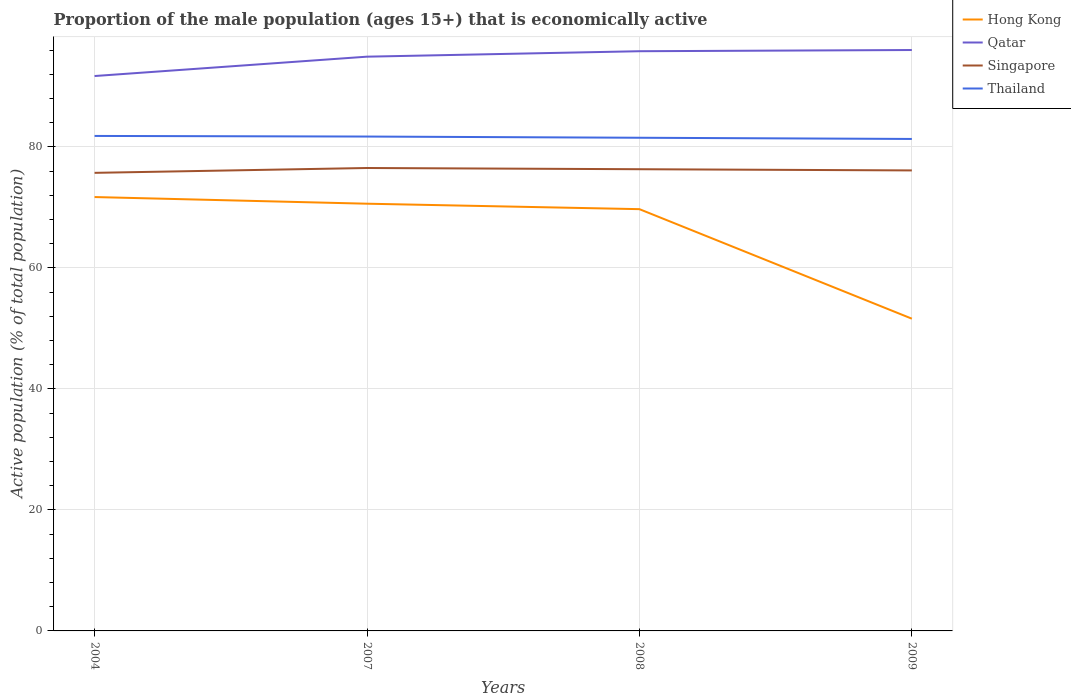How many different coloured lines are there?
Give a very brief answer. 4. Does the line corresponding to Hong Kong intersect with the line corresponding to Singapore?
Provide a short and direct response. No. Across all years, what is the maximum proportion of the male population that is economically active in Singapore?
Offer a terse response. 75.7. What is the total proportion of the male population that is economically active in Qatar in the graph?
Offer a very short reply. -4.3. What is the difference between the highest and the second highest proportion of the male population that is economically active in Singapore?
Make the answer very short. 0.8. What is the difference between the highest and the lowest proportion of the male population that is economically active in Singapore?
Provide a short and direct response. 2. How many lines are there?
Provide a short and direct response. 4. How many years are there in the graph?
Your answer should be very brief. 4. Are the values on the major ticks of Y-axis written in scientific E-notation?
Your answer should be very brief. No. Where does the legend appear in the graph?
Make the answer very short. Top right. What is the title of the graph?
Your answer should be compact. Proportion of the male population (ages 15+) that is economically active. What is the label or title of the Y-axis?
Offer a terse response. Active population (% of total population). What is the Active population (% of total population) of Hong Kong in 2004?
Your answer should be very brief. 71.7. What is the Active population (% of total population) in Qatar in 2004?
Your answer should be very brief. 91.7. What is the Active population (% of total population) in Singapore in 2004?
Offer a very short reply. 75.7. What is the Active population (% of total population) of Thailand in 2004?
Ensure brevity in your answer.  81.8. What is the Active population (% of total population) of Hong Kong in 2007?
Offer a terse response. 70.6. What is the Active population (% of total population) in Qatar in 2007?
Offer a very short reply. 94.9. What is the Active population (% of total population) of Singapore in 2007?
Give a very brief answer. 76.5. What is the Active population (% of total population) in Thailand in 2007?
Your response must be concise. 81.7. What is the Active population (% of total population) of Hong Kong in 2008?
Provide a succinct answer. 69.7. What is the Active population (% of total population) in Qatar in 2008?
Offer a very short reply. 95.8. What is the Active population (% of total population) in Singapore in 2008?
Your answer should be very brief. 76.3. What is the Active population (% of total population) in Thailand in 2008?
Give a very brief answer. 81.5. What is the Active population (% of total population) of Hong Kong in 2009?
Provide a succinct answer. 51.6. What is the Active population (% of total population) in Qatar in 2009?
Ensure brevity in your answer.  96. What is the Active population (% of total population) in Singapore in 2009?
Ensure brevity in your answer.  76.1. What is the Active population (% of total population) of Thailand in 2009?
Make the answer very short. 81.3. Across all years, what is the maximum Active population (% of total population) of Hong Kong?
Your answer should be compact. 71.7. Across all years, what is the maximum Active population (% of total population) of Qatar?
Keep it short and to the point. 96. Across all years, what is the maximum Active population (% of total population) in Singapore?
Give a very brief answer. 76.5. Across all years, what is the maximum Active population (% of total population) of Thailand?
Make the answer very short. 81.8. Across all years, what is the minimum Active population (% of total population) of Hong Kong?
Your answer should be compact. 51.6. Across all years, what is the minimum Active population (% of total population) of Qatar?
Your answer should be compact. 91.7. Across all years, what is the minimum Active population (% of total population) of Singapore?
Ensure brevity in your answer.  75.7. Across all years, what is the minimum Active population (% of total population) of Thailand?
Ensure brevity in your answer.  81.3. What is the total Active population (% of total population) of Hong Kong in the graph?
Your answer should be very brief. 263.6. What is the total Active population (% of total population) of Qatar in the graph?
Keep it short and to the point. 378.4. What is the total Active population (% of total population) in Singapore in the graph?
Your answer should be very brief. 304.6. What is the total Active population (% of total population) of Thailand in the graph?
Your answer should be very brief. 326.3. What is the difference between the Active population (% of total population) of Qatar in 2004 and that in 2007?
Provide a short and direct response. -3.2. What is the difference between the Active population (% of total population) of Qatar in 2004 and that in 2008?
Provide a succinct answer. -4.1. What is the difference between the Active population (% of total population) in Hong Kong in 2004 and that in 2009?
Give a very brief answer. 20.1. What is the difference between the Active population (% of total population) of Qatar in 2004 and that in 2009?
Provide a succinct answer. -4.3. What is the difference between the Active population (% of total population) in Thailand in 2004 and that in 2009?
Offer a terse response. 0.5. What is the difference between the Active population (% of total population) of Singapore in 2007 and that in 2008?
Your response must be concise. 0.2. What is the difference between the Active population (% of total population) in Thailand in 2007 and that in 2008?
Give a very brief answer. 0.2. What is the difference between the Active population (% of total population) of Hong Kong in 2007 and that in 2009?
Provide a short and direct response. 19. What is the difference between the Active population (% of total population) of Thailand in 2007 and that in 2009?
Keep it short and to the point. 0.4. What is the difference between the Active population (% of total population) in Qatar in 2008 and that in 2009?
Your answer should be very brief. -0.2. What is the difference between the Active population (% of total population) in Singapore in 2008 and that in 2009?
Your answer should be compact. 0.2. What is the difference between the Active population (% of total population) of Thailand in 2008 and that in 2009?
Ensure brevity in your answer.  0.2. What is the difference between the Active population (% of total population) of Hong Kong in 2004 and the Active population (% of total population) of Qatar in 2007?
Offer a very short reply. -23.2. What is the difference between the Active population (% of total population) of Qatar in 2004 and the Active population (% of total population) of Thailand in 2007?
Ensure brevity in your answer.  10. What is the difference between the Active population (% of total population) in Hong Kong in 2004 and the Active population (% of total population) in Qatar in 2008?
Your answer should be very brief. -24.1. What is the difference between the Active population (% of total population) of Hong Kong in 2004 and the Active population (% of total population) of Singapore in 2008?
Offer a very short reply. -4.6. What is the difference between the Active population (% of total population) in Singapore in 2004 and the Active population (% of total population) in Thailand in 2008?
Make the answer very short. -5.8. What is the difference between the Active population (% of total population) of Hong Kong in 2004 and the Active population (% of total population) of Qatar in 2009?
Your answer should be compact. -24.3. What is the difference between the Active population (% of total population) of Hong Kong in 2004 and the Active population (% of total population) of Singapore in 2009?
Make the answer very short. -4.4. What is the difference between the Active population (% of total population) of Hong Kong in 2004 and the Active population (% of total population) of Thailand in 2009?
Give a very brief answer. -9.6. What is the difference between the Active population (% of total population) of Qatar in 2004 and the Active population (% of total population) of Singapore in 2009?
Make the answer very short. 15.6. What is the difference between the Active population (% of total population) in Qatar in 2004 and the Active population (% of total population) in Thailand in 2009?
Your answer should be very brief. 10.4. What is the difference between the Active population (% of total population) in Singapore in 2004 and the Active population (% of total population) in Thailand in 2009?
Your answer should be very brief. -5.6. What is the difference between the Active population (% of total population) in Hong Kong in 2007 and the Active population (% of total population) in Qatar in 2008?
Keep it short and to the point. -25.2. What is the difference between the Active population (% of total population) in Qatar in 2007 and the Active population (% of total population) in Singapore in 2008?
Your response must be concise. 18.6. What is the difference between the Active population (% of total population) of Hong Kong in 2007 and the Active population (% of total population) of Qatar in 2009?
Your response must be concise. -25.4. What is the difference between the Active population (% of total population) of Hong Kong in 2007 and the Active population (% of total population) of Thailand in 2009?
Give a very brief answer. -10.7. What is the difference between the Active population (% of total population) of Qatar in 2007 and the Active population (% of total population) of Singapore in 2009?
Keep it short and to the point. 18.8. What is the difference between the Active population (% of total population) of Singapore in 2007 and the Active population (% of total population) of Thailand in 2009?
Offer a very short reply. -4.8. What is the difference between the Active population (% of total population) in Hong Kong in 2008 and the Active population (% of total population) in Qatar in 2009?
Make the answer very short. -26.3. What is the difference between the Active population (% of total population) in Hong Kong in 2008 and the Active population (% of total population) in Singapore in 2009?
Provide a short and direct response. -6.4. What is the difference between the Active population (% of total population) in Hong Kong in 2008 and the Active population (% of total population) in Thailand in 2009?
Your response must be concise. -11.6. What is the difference between the Active population (% of total population) of Qatar in 2008 and the Active population (% of total population) of Singapore in 2009?
Ensure brevity in your answer.  19.7. What is the average Active population (% of total population) of Hong Kong per year?
Keep it short and to the point. 65.9. What is the average Active population (% of total population) in Qatar per year?
Provide a short and direct response. 94.6. What is the average Active population (% of total population) in Singapore per year?
Your response must be concise. 76.15. What is the average Active population (% of total population) of Thailand per year?
Offer a very short reply. 81.58. In the year 2004, what is the difference between the Active population (% of total population) in Hong Kong and Active population (% of total population) in Thailand?
Give a very brief answer. -10.1. In the year 2004, what is the difference between the Active population (% of total population) of Qatar and Active population (% of total population) of Thailand?
Offer a very short reply. 9.9. In the year 2004, what is the difference between the Active population (% of total population) in Singapore and Active population (% of total population) in Thailand?
Offer a very short reply. -6.1. In the year 2007, what is the difference between the Active population (% of total population) in Hong Kong and Active population (% of total population) in Qatar?
Your response must be concise. -24.3. In the year 2007, what is the difference between the Active population (% of total population) of Hong Kong and Active population (% of total population) of Thailand?
Offer a very short reply. -11.1. In the year 2007, what is the difference between the Active population (% of total population) of Qatar and Active population (% of total population) of Thailand?
Ensure brevity in your answer.  13.2. In the year 2008, what is the difference between the Active population (% of total population) of Hong Kong and Active population (% of total population) of Qatar?
Your answer should be very brief. -26.1. In the year 2008, what is the difference between the Active population (% of total population) in Qatar and Active population (% of total population) in Singapore?
Give a very brief answer. 19.5. In the year 2008, what is the difference between the Active population (% of total population) of Qatar and Active population (% of total population) of Thailand?
Provide a short and direct response. 14.3. In the year 2009, what is the difference between the Active population (% of total population) of Hong Kong and Active population (% of total population) of Qatar?
Ensure brevity in your answer.  -44.4. In the year 2009, what is the difference between the Active population (% of total population) in Hong Kong and Active population (% of total population) in Singapore?
Provide a short and direct response. -24.5. In the year 2009, what is the difference between the Active population (% of total population) in Hong Kong and Active population (% of total population) in Thailand?
Give a very brief answer. -29.7. What is the ratio of the Active population (% of total population) of Hong Kong in 2004 to that in 2007?
Ensure brevity in your answer.  1.02. What is the ratio of the Active population (% of total population) of Qatar in 2004 to that in 2007?
Give a very brief answer. 0.97. What is the ratio of the Active population (% of total population) of Singapore in 2004 to that in 2007?
Ensure brevity in your answer.  0.99. What is the ratio of the Active population (% of total population) of Hong Kong in 2004 to that in 2008?
Ensure brevity in your answer.  1.03. What is the ratio of the Active population (% of total population) in Qatar in 2004 to that in 2008?
Offer a terse response. 0.96. What is the ratio of the Active population (% of total population) in Thailand in 2004 to that in 2008?
Keep it short and to the point. 1. What is the ratio of the Active population (% of total population) of Hong Kong in 2004 to that in 2009?
Provide a succinct answer. 1.39. What is the ratio of the Active population (% of total population) in Qatar in 2004 to that in 2009?
Your response must be concise. 0.96. What is the ratio of the Active population (% of total population) of Singapore in 2004 to that in 2009?
Keep it short and to the point. 0.99. What is the ratio of the Active population (% of total population) in Thailand in 2004 to that in 2009?
Your response must be concise. 1.01. What is the ratio of the Active population (% of total population) of Hong Kong in 2007 to that in 2008?
Offer a very short reply. 1.01. What is the ratio of the Active population (% of total population) in Qatar in 2007 to that in 2008?
Provide a short and direct response. 0.99. What is the ratio of the Active population (% of total population) in Hong Kong in 2007 to that in 2009?
Provide a succinct answer. 1.37. What is the ratio of the Active population (% of total population) of Qatar in 2007 to that in 2009?
Provide a short and direct response. 0.99. What is the ratio of the Active population (% of total population) in Thailand in 2007 to that in 2009?
Your response must be concise. 1. What is the ratio of the Active population (% of total population) in Hong Kong in 2008 to that in 2009?
Give a very brief answer. 1.35. What is the ratio of the Active population (% of total population) of Singapore in 2008 to that in 2009?
Make the answer very short. 1. What is the ratio of the Active population (% of total population) of Thailand in 2008 to that in 2009?
Your answer should be compact. 1. What is the difference between the highest and the second highest Active population (% of total population) in Thailand?
Ensure brevity in your answer.  0.1. What is the difference between the highest and the lowest Active population (% of total population) in Hong Kong?
Your answer should be compact. 20.1. What is the difference between the highest and the lowest Active population (% of total population) in Qatar?
Your response must be concise. 4.3. What is the difference between the highest and the lowest Active population (% of total population) in Singapore?
Give a very brief answer. 0.8. 